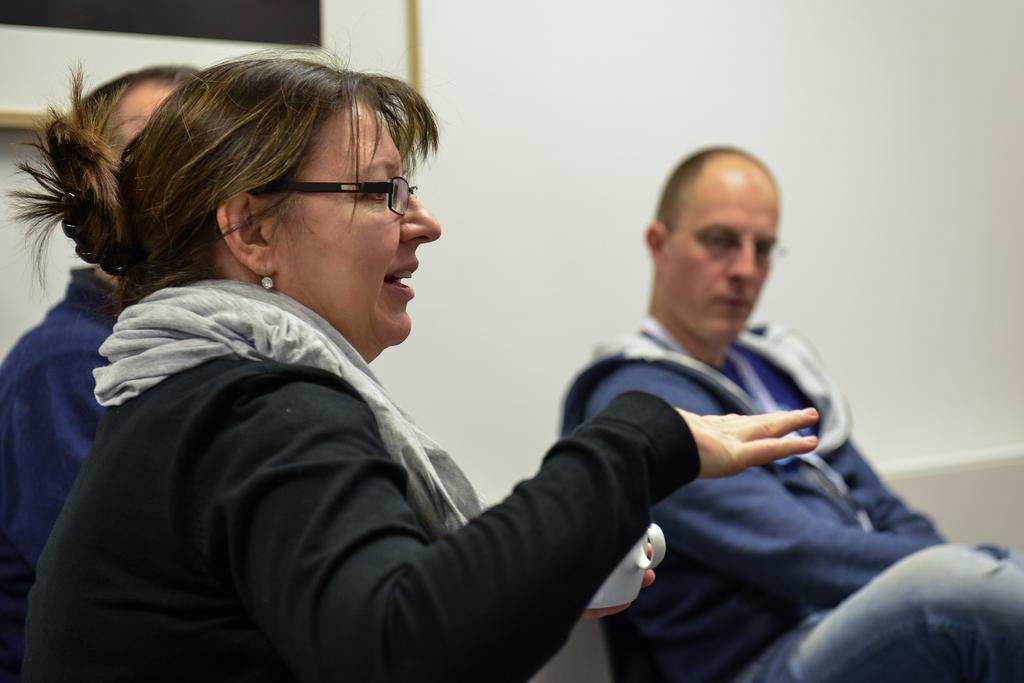Who is the main subject in the foreground of the image? There is a woman in the foreground of the image. What is the woman wearing? The woman is wearing a black dress. What is the woman holding in the image? The woman is holding a cup. How many people are in the middle of the image? There are two persons in the middle of the image. What can be seen in the background of the image? There is a wall and a frame in the background of the image. What is the price of the voyage depicted in the image? There is no voyage depicted in the image, so there is no price to consider. 